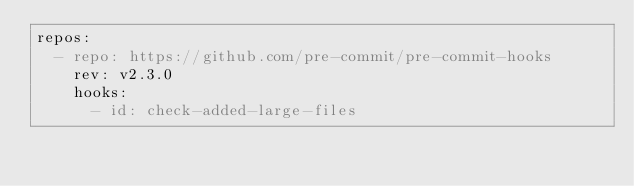<code> <loc_0><loc_0><loc_500><loc_500><_YAML_>repos:
  - repo: https://github.com/pre-commit/pre-commit-hooks
    rev: v2.3.0
    hooks:
      - id: check-added-large-files</code> 